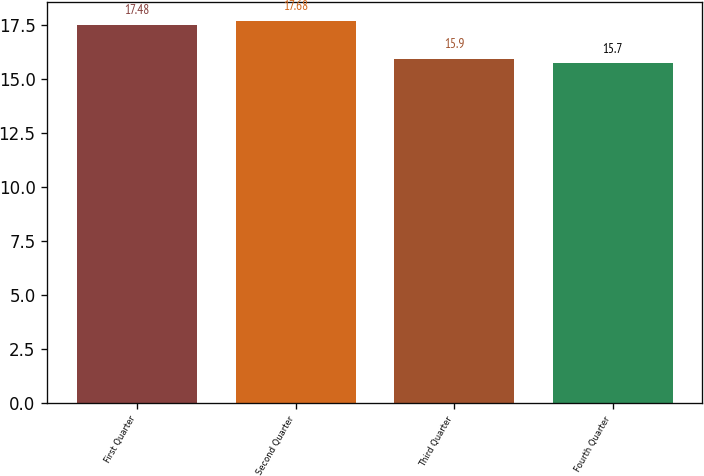<chart> <loc_0><loc_0><loc_500><loc_500><bar_chart><fcel>First Quarter<fcel>Second Quarter<fcel>Third Quarter<fcel>Fourth Quarter<nl><fcel>17.48<fcel>17.68<fcel>15.9<fcel>15.7<nl></chart> 